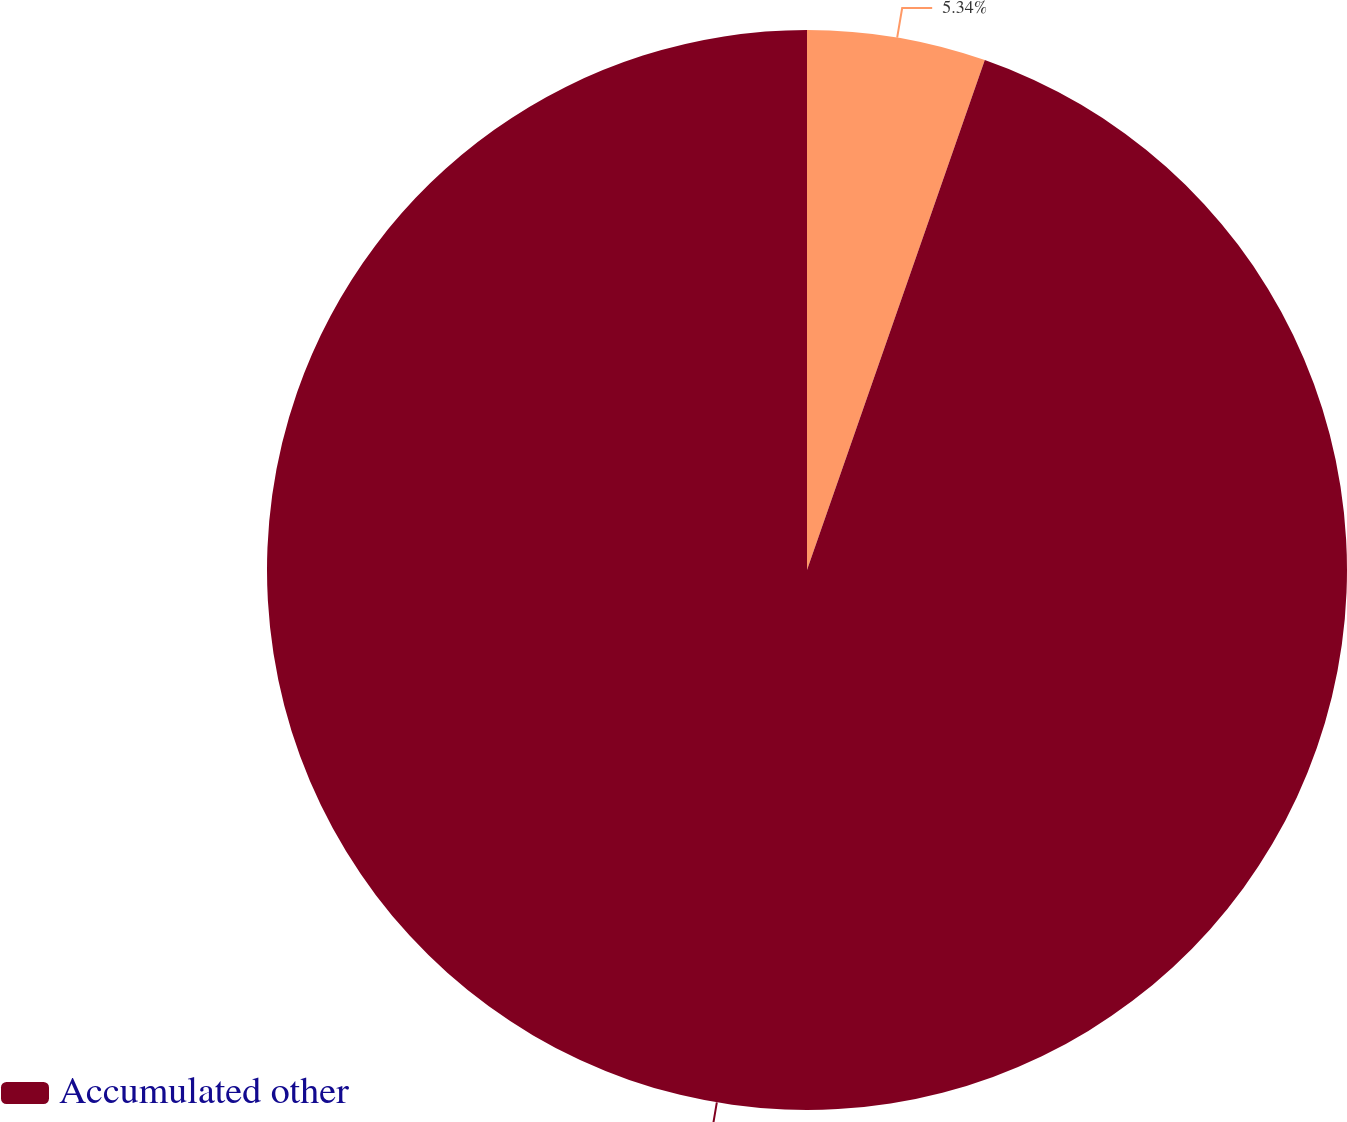Convert chart to OTSL. <chart><loc_0><loc_0><loc_500><loc_500><pie_chart><ecel><fcel>Accumulated other<nl><fcel>5.34%<fcel>94.66%<nl></chart> 